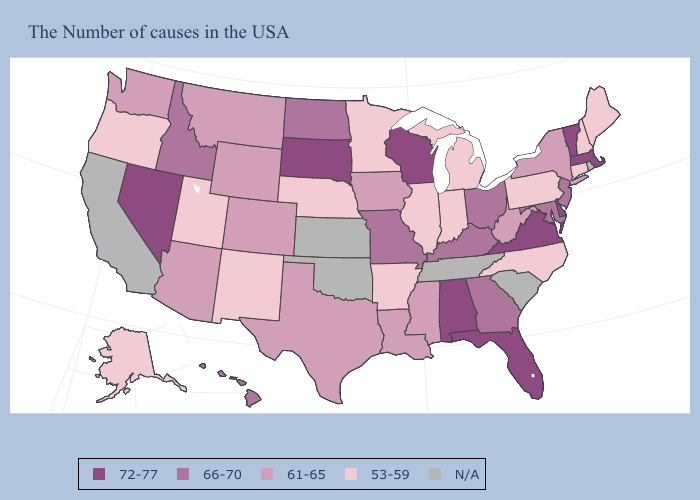Does Minnesota have the lowest value in the USA?
Short answer required. Yes. Name the states that have a value in the range 53-59?
Quick response, please. Maine, New Hampshire, Connecticut, Pennsylvania, North Carolina, Michigan, Indiana, Illinois, Arkansas, Minnesota, Nebraska, New Mexico, Utah, Oregon, Alaska. Does Vermont have the highest value in the Northeast?
Write a very short answer. Yes. Name the states that have a value in the range N/A?
Keep it brief. Rhode Island, South Carolina, Tennessee, Kansas, Oklahoma, California. Name the states that have a value in the range 66-70?
Keep it brief. New Jersey, Maryland, Ohio, Georgia, Kentucky, Missouri, North Dakota, Idaho, Hawaii. Is the legend a continuous bar?
Quick response, please. No. Among the states that border Washington , which have the highest value?
Give a very brief answer. Idaho. Which states have the highest value in the USA?
Give a very brief answer. Massachusetts, Vermont, Delaware, Virginia, Florida, Alabama, Wisconsin, South Dakota, Nevada. Does Indiana have the lowest value in the USA?
Be succinct. Yes. Among the states that border Tennessee , which have the highest value?
Quick response, please. Virginia, Alabama. What is the value of Mississippi?
Concise answer only. 61-65. Name the states that have a value in the range 72-77?
Give a very brief answer. Massachusetts, Vermont, Delaware, Virginia, Florida, Alabama, Wisconsin, South Dakota, Nevada. How many symbols are there in the legend?
Concise answer only. 5. 